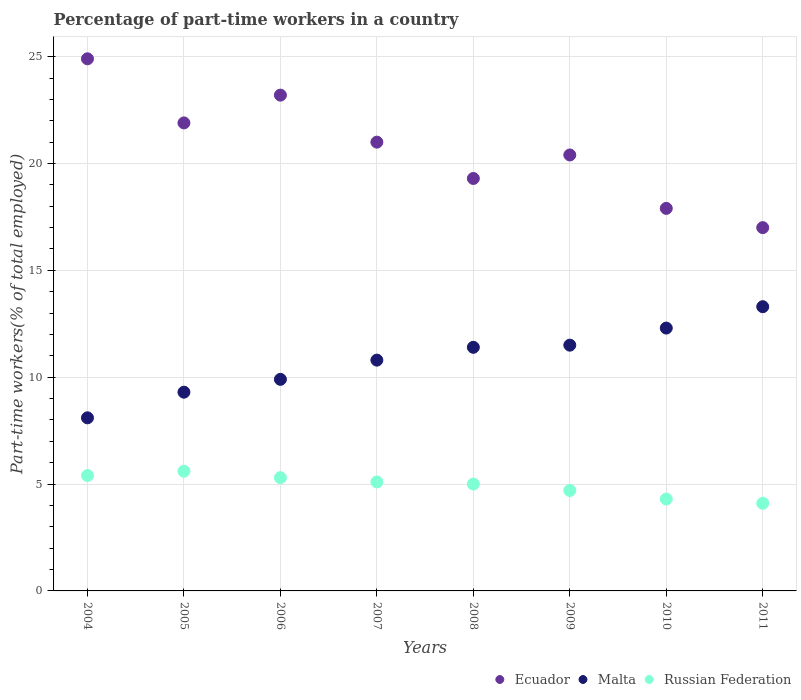Is the number of dotlines equal to the number of legend labels?
Give a very brief answer. Yes. What is the percentage of part-time workers in Malta in 2006?
Your response must be concise. 9.9. Across all years, what is the maximum percentage of part-time workers in Malta?
Ensure brevity in your answer.  13.3. Across all years, what is the minimum percentage of part-time workers in Russian Federation?
Give a very brief answer. 4.1. What is the total percentage of part-time workers in Russian Federation in the graph?
Keep it short and to the point. 39.5. What is the difference between the percentage of part-time workers in Malta in 2006 and that in 2009?
Your response must be concise. -1.6. What is the difference between the percentage of part-time workers in Ecuador in 2010 and the percentage of part-time workers in Malta in 2007?
Your answer should be compact. 7.1. What is the average percentage of part-time workers in Ecuador per year?
Your answer should be compact. 20.7. In the year 2008, what is the difference between the percentage of part-time workers in Malta and percentage of part-time workers in Ecuador?
Provide a short and direct response. -7.9. What is the ratio of the percentage of part-time workers in Russian Federation in 2007 to that in 2009?
Offer a terse response. 1.09. What is the difference between the highest and the second highest percentage of part-time workers in Ecuador?
Provide a short and direct response. 1.7. What is the difference between the highest and the lowest percentage of part-time workers in Russian Federation?
Keep it short and to the point. 1.5. In how many years, is the percentage of part-time workers in Ecuador greater than the average percentage of part-time workers in Ecuador taken over all years?
Provide a succinct answer. 4. Is the percentage of part-time workers in Russian Federation strictly greater than the percentage of part-time workers in Malta over the years?
Your response must be concise. No. How many years are there in the graph?
Provide a short and direct response. 8. What is the difference between two consecutive major ticks on the Y-axis?
Your answer should be very brief. 5. Are the values on the major ticks of Y-axis written in scientific E-notation?
Provide a short and direct response. No. Where does the legend appear in the graph?
Provide a short and direct response. Bottom right. What is the title of the graph?
Offer a very short reply. Percentage of part-time workers in a country. What is the label or title of the Y-axis?
Make the answer very short. Part-time workers(% of total employed). What is the Part-time workers(% of total employed) of Ecuador in 2004?
Your response must be concise. 24.9. What is the Part-time workers(% of total employed) in Malta in 2004?
Provide a succinct answer. 8.1. What is the Part-time workers(% of total employed) in Russian Federation in 2004?
Keep it short and to the point. 5.4. What is the Part-time workers(% of total employed) of Ecuador in 2005?
Offer a terse response. 21.9. What is the Part-time workers(% of total employed) of Malta in 2005?
Make the answer very short. 9.3. What is the Part-time workers(% of total employed) in Russian Federation in 2005?
Ensure brevity in your answer.  5.6. What is the Part-time workers(% of total employed) in Ecuador in 2006?
Offer a very short reply. 23.2. What is the Part-time workers(% of total employed) in Malta in 2006?
Your response must be concise. 9.9. What is the Part-time workers(% of total employed) in Russian Federation in 2006?
Keep it short and to the point. 5.3. What is the Part-time workers(% of total employed) in Malta in 2007?
Your response must be concise. 10.8. What is the Part-time workers(% of total employed) of Russian Federation in 2007?
Make the answer very short. 5.1. What is the Part-time workers(% of total employed) of Ecuador in 2008?
Give a very brief answer. 19.3. What is the Part-time workers(% of total employed) of Malta in 2008?
Your response must be concise. 11.4. What is the Part-time workers(% of total employed) in Ecuador in 2009?
Your answer should be very brief. 20.4. What is the Part-time workers(% of total employed) in Malta in 2009?
Make the answer very short. 11.5. What is the Part-time workers(% of total employed) of Russian Federation in 2009?
Your answer should be compact. 4.7. What is the Part-time workers(% of total employed) in Ecuador in 2010?
Keep it short and to the point. 17.9. What is the Part-time workers(% of total employed) in Malta in 2010?
Ensure brevity in your answer.  12.3. What is the Part-time workers(% of total employed) in Russian Federation in 2010?
Offer a terse response. 4.3. What is the Part-time workers(% of total employed) of Malta in 2011?
Provide a succinct answer. 13.3. What is the Part-time workers(% of total employed) in Russian Federation in 2011?
Ensure brevity in your answer.  4.1. Across all years, what is the maximum Part-time workers(% of total employed) in Ecuador?
Offer a terse response. 24.9. Across all years, what is the maximum Part-time workers(% of total employed) in Malta?
Your answer should be very brief. 13.3. Across all years, what is the maximum Part-time workers(% of total employed) in Russian Federation?
Offer a very short reply. 5.6. Across all years, what is the minimum Part-time workers(% of total employed) of Ecuador?
Make the answer very short. 17. Across all years, what is the minimum Part-time workers(% of total employed) of Malta?
Your answer should be compact. 8.1. Across all years, what is the minimum Part-time workers(% of total employed) in Russian Federation?
Ensure brevity in your answer.  4.1. What is the total Part-time workers(% of total employed) in Ecuador in the graph?
Your answer should be compact. 165.6. What is the total Part-time workers(% of total employed) in Malta in the graph?
Keep it short and to the point. 86.6. What is the total Part-time workers(% of total employed) of Russian Federation in the graph?
Make the answer very short. 39.5. What is the difference between the Part-time workers(% of total employed) in Ecuador in 2004 and that in 2005?
Your response must be concise. 3. What is the difference between the Part-time workers(% of total employed) in Russian Federation in 2004 and that in 2005?
Make the answer very short. -0.2. What is the difference between the Part-time workers(% of total employed) in Ecuador in 2004 and that in 2006?
Provide a short and direct response. 1.7. What is the difference between the Part-time workers(% of total employed) in Russian Federation in 2004 and that in 2006?
Offer a terse response. 0.1. What is the difference between the Part-time workers(% of total employed) in Ecuador in 2004 and that in 2007?
Your answer should be compact. 3.9. What is the difference between the Part-time workers(% of total employed) in Malta in 2004 and that in 2008?
Make the answer very short. -3.3. What is the difference between the Part-time workers(% of total employed) of Russian Federation in 2004 and that in 2008?
Keep it short and to the point. 0.4. What is the difference between the Part-time workers(% of total employed) in Malta in 2004 and that in 2009?
Your answer should be compact. -3.4. What is the difference between the Part-time workers(% of total employed) of Russian Federation in 2004 and that in 2009?
Offer a terse response. 0.7. What is the difference between the Part-time workers(% of total employed) in Malta in 2004 and that in 2011?
Provide a short and direct response. -5.2. What is the difference between the Part-time workers(% of total employed) in Ecuador in 2005 and that in 2006?
Your response must be concise. -1.3. What is the difference between the Part-time workers(% of total employed) in Russian Federation in 2005 and that in 2006?
Provide a succinct answer. 0.3. What is the difference between the Part-time workers(% of total employed) of Ecuador in 2005 and that in 2007?
Keep it short and to the point. 0.9. What is the difference between the Part-time workers(% of total employed) of Malta in 2005 and that in 2007?
Give a very brief answer. -1.5. What is the difference between the Part-time workers(% of total employed) in Russian Federation in 2005 and that in 2007?
Offer a very short reply. 0.5. What is the difference between the Part-time workers(% of total employed) of Russian Federation in 2005 and that in 2010?
Provide a short and direct response. 1.3. What is the difference between the Part-time workers(% of total employed) in Ecuador in 2005 and that in 2011?
Your response must be concise. 4.9. What is the difference between the Part-time workers(% of total employed) of Malta in 2006 and that in 2007?
Ensure brevity in your answer.  -0.9. What is the difference between the Part-time workers(% of total employed) in Malta in 2006 and that in 2008?
Keep it short and to the point. -1.5. What is the difference between the Part-time workers(% of total employed) in Ecuador in 2006 and that in 2009?
Offer a terse response. 2.8. What is the difference between the Part-time workers(% of total employed) in Ecuador in 2006 and that in 2010?
Offer a terse response. 5.3. What is the difference between the Part-time workers(% of total employed) in Malta in 2006 and that in 2010?
Offer a terse response. -2.4. What is the difference between the Part-time workers(% of total employed) of Ecuador in 2006 and that in 2011?
Your answer should be very brief. 6.2. What is the difference between the Part-time workers(% of total employed) in Malta in 2006 and that in 2011?
Offer a terse response. -3.4. What is the difference between the Part-time workers(% of total employed) in Ecuador in 2007 and that in 2008?
Offer a terse response. 1.7. What is the difference between the Part-time workers(% of total employed) in Malta in 2007 and that in 2008?
Give a very brief answer. -0.6. What is the difference between the Part-time workers(% of total employed) in Russian Federation in 2007 and that in 2008?
Keep it short and to the point. 0.1. What is the difference between the Part-time workers(% of total employed) in Ecuador in 2007 and that in 2009?
Offer a very short reply. 0.6. What is the difference between the Part-time workers(% of total employed) of Malta in 2007 and that in 2010?
Your answer should be very brief. -1.5. What is the difference between the Part-time workers(% of total employed) of Russian Federation in 2007 and that in 2010?
Keep it short and to the point. 0.8. What is the difference between the Part-time workers(% of total employed) in Ecuador in 2007 and that in 2011?
Provide a succinct answer. 4. What is the difference between the Part-time workers(% of total employed) of Malta in 2008 and that in 2009?
Provide a succinct answer. -0.1. What is the difference between the Part-time workers(% of total employed) in Malta in 2008 and that in 2010?
Make the answer very short. -0.9. What is the difference between the Part-time workers(% of total employed) in Ecuador in 2008 and that in 2011?
Your answer should be very brief. 2.3. What is the difference between the Part-time workers(% of total employed) of Malta in 2008 and that in 2011?
Offer a very short reply. -1.9. What is the difference between the Part-time workers(% of total employed) of Russian Federation in 2008 and that in 2011?
Provide a short and direct response. 0.9. What is the difference between the Part-time workers(% of total employed) in Ecuador in 2009 and that in 2010?
Offer a terse response. 2.5. What is the difference between the Part-time workers(% of total employed) in Malta in 2009 and that in 2010?
Ensure brevity in your answer.  -0.8. What is the difference between the Part-time workers(% of total employed) in Ecuador in 2009 and that in 2011?
Your answer should be compact. 3.4. What is the difference between the Part-time workers(% of total employed) in Malta in 2009 and that in 2011?
Give a very brief answer. -1.8. What is the difference between the Part-time workers(% of total employed) in Russian Federation in 2009 and that in 2011?
Provide a succinct answer. 0.6. What is the difference between the Part-time workers(% of total employed) in Ecuador in 2010 and that in 2011?
Offer a very short reply. 0.9. What is the difference between the Part-time workers(% of total employed) in Malta in 2010 and that in 2011?
Your answer should be very brief. -1. What is the difference between the Part-time workers(% of total employed) in Ecuador in 2004 and the Part-time workers(% of total employed) in Russian Federation in 2005?
Your answer should be very brief. 19.3. What is the difference between the Part-time workers(% of total employed) of Malta in 2004 and the Part-time workers(% of total employed) of Russian Federation in 2005?
Keep it short and to the point. 2.5. What is the difference between the Part-time workers(% of total employed) of Ecuador in 2004 and the Part-time workers(% of total employed) of Russian Federation in 2006?
Offer a very short reply. 19.6. What is the difference between the Part-time workers(% of total employed) in Malta in 2004 and the Part-time workers(% of total employed) in Russian Federation in 2006?
Ensure brevity in your answer.  2.8. What is the difference between the Part-time workers(% of total employed) in Ecuador in 2004 and the Part-time workers(% of total employed) in Malta in 2007?
Offer a very short reply. 14.1. What is the difference between the Part-time workers(% of total employed) of Ecuador in 2004 and the Part-time workers(% of total employed) of Russian Federation in 2007?
Offer a very short reply. 19.8. What is the difference between the Part-time workers(% of total employed) of Malta in 2004 and the Part-time workers(% of total employed) of Russian Federation in 2008?
Provide a short and direct response. 3.1. What is the difference between the Part-time workers(% of total employed) of Ecuador in 2004 and the Part-time workers(% of total employed) of Russian Federation in 2009?
Ensure brevity in your answer.  20.2. What is the difference between the Part-time workers(% of total employed) in Ecuador in 2004 and the Part-time workers(% of total employed) in Malta in 2010?
Provide a succinct answer. 12.6. What is the difference between the Part-time workers(% of total employed) in Ecuador in 2004 and the Part-time workers(% of total employed) in Russian Federation in 2010?
Provide a short and direct response. 20.6. What is the difference between the Part-time workers(% of total employed) in Malta in 2004 and the Part-time workers(% of total employed) in Russian Federation in 2010?
Offer a terse response. 3.8. What is the difference between the Part-time workers(% of total employed) in Ecuador in 2004 and the Part-time workers(% of total employed) in Malta in 2011?
Ensure brevity in your answer.  11.6. What is the difference between the Part-time workers(% of total employed) in Ecuador in 2004 and the Part-time workers(% of total employed) in Russian Federation in 2011?
Keep it short and to the point. 20.8. What is the difference between the Part-time workers(% of total employed) of Malta in 2004 and the Part-time workers(% of total employed) of Russian Federation in 2011?
Keep it short and to the point. 4. What is the difference between the Part-time workers(% of total employed) of Malta in 2005 and the Part-time workers(% of total employed) of Russian Federation in 2006?
Offer a very short reply. 4. What is the difference between the Part-time workers(% of total employed) in Malta in 2005 and the Part-time workers(% of total employed) in Russian Federation in 2008?
Provide a succinct answer. 4.3. What is the difference between the Part-time workers(% of total employed) in Ecuador in 2005 and the Part-time workers(% of total employed) in Malta in 2009?
Your answer should be compact. 10.4. What is the difference between the Part-time workers(% of total employed) in Ecuador in 2005 and the Part-time workers(% of total employed) in Russian Federation in 2009?
Provide a succinct answer. 17.2. What is the difference between the Part-time workers(% of total employed) in Ecuador in 2005 and the Part-time workers(% of total employed) in Russian Federation in 2010?
Give a very brief answer. 17.6. What is the difference between the Part-time workers(% of total employed) of Malta in 2005 and the Part-time workers(% of total employed) of Russian Federation in 2010?
Your answer should be very brief. 5. What is the difference between the Part-time workers(% of total employed) of Ecuador in 2005 and the Part-time workers(% of total employed) of Russian Federation in 2011?
Your answer should be compact. 17.8. What is the difference between the Part-time workers(% of total employed) of Ecuador in 2006 and the Part-time workers(% of total employed) of Malta in 2007?
Provide a short and direct response. 12.4. What is the difference between the Part-time workers(% of total employed) of Ecuador in 2006 and the Part-time workers(% of total employed) of Russian Federation in 2008?
Your response must be concise. 18.2. What is the difference between the Part-time workers(% of total employed) in Ecuador in 2006 and the Part-time workers(% of total employed) in Malta in 2009?
Offer a very short reply. 11.7. What is the difference between the Part-time workers(% of total employed) of Malta in 2006 and the Part-time workers(% of total employed) of Russian Federation in 2009?
Provide a short and direct response. 5.2. What is the difference between the Part-time workers(% of total employed) of Ecuador in 2007 and the Part-time workers(% of total employed) of Russian Federation in 2008?
Ensure brevity in your answer.  16. What is the difference between the Part-time workers(% of total employed) of Ecuador in 2007 and the Part-time workers(% of total employed) of Malta in 2009?
Ensure brevity in your answer.  9.5. What is the difference between the Part-time workers(% of total employed) in Malta in 2007 and the Part-time workers(% of total employed) in Russian Federation in 2009?
Your response must be concise. 6.1. What is the difference between the Part-time workers(% of total employed) of Ecuador in 2007 and the Part-time workers(% of total employed) of Russian Federation in 2010?
Your answer should be compact. 16.7. What is the difference between the Part-time workers(% of total employed) in Ecuador in 2007 and the Part-time workers(% of total employed) in Russian Federation in 2011?
Provide a short and direct response. 16.9. What is the difference between the Part-time workers(% of total employed) of Ecuador in 2008 and the Part-time workers(% of total employed) of Malta in 2009?
Provide a short and direct response. 7.8. What is the difference between the Part-time workers(% of total employed) in Malta in 2008 and the Part-time workers(% of total employed) in Russian Federation in 2009?
Offer a very short reply. 6.7. What is the difference between the Part-time workers(% of total employed) of Malta in 2008 and the Part-time workers(% of total employed) of Russian Federation in 2010?
Provide a succinct answer. 7.1. What is the difference between the Part-time workers(% of total employed) in Ecuador in 2008 and the Part-time workers(% of total employed) in Russian Federation in 2011?
Your answer should be very brief. 15.2. What is the difference between the Part-time workers(% of total employed) in Ecuador in 2009 and the Part-time workers(% of total employed) in Malta in 2011?
Provide a succinct answer. 7.1. What is the difference between the Part-time workers(% of total employed) of Ecuador in 2009 and the Part-time workers(% of total employed) of Russian Federation in 2011?
Your response must be concise. 16.3. What is the difference between the Part-time workers(% of total employed) of Ecuador in 2010 and the Part-time workers(% of total employed) of Russian Federation in 2011?
Provide a succinct answer. 13.8. What is the difference between the Part-time workers(% of total employed) in Malta in 2010 and the Part-time workers(% of total employed) in Russian Federation in 2011?
Ensure brevity in your answer.  8.2. What is the average Part-time workers(% of total employed) in Ecuador per year?
Keep it short and to the point. 20.7. What is the average Part-time workers(% of total employed) in Malta per year?
Provide a succinct answer. 10.82. What is the average Part-time workers(% of total employed) in Russian Federation per year?
Provide a succinct answer. 4.94. In the year 2004, what is the difference between the Part-time workers(% of total employed) of Malta and Part-time workers(% of total employed) of Russian Federation?
Your answer should be very brief. 2.7. In the year 2005, what is the difference between the Part-time workers(% of total employed) of Ecuador and Part-time workers(% of total employed) of Russian Federation?
Make the answer very short. 16.3. In the year 2006, what is the difference between the Part-time workers(% of total employed) of Ecuador and Part-time workers(% of total employed) of Malta?
Make the answer very short. 13.3. In the year 2007, what is the difference between the Part-time workers(% of total employed) of Ecuador and Part-time workers(% of total employed) of Russian Federation?
Offer a very short reply. 15.9. In the year 2007, what is the difference between the Part-time workers(% of total employed) in Malta and Part-time workers(% of total employed) in Russian Federation?
Offer a terse response. 5.7. In the year 2008, what is the difference between the Part-time workers(% of total employed) of Ecuador and Part-time workers(% of total employed) of Malta?
Provide a short and direct response. 7.9. In the year 2008, what is the difference between the Part-time workers(% of total employed) in Ecuador and Part-time workers(% of total employed) in Russian Federation?
Ensure brevity in your answer.  14.3. In the year 2009, what is the difference between the Part-time workers(% of total employed) of Ecuador and Part-time workers(% of total employed) of Malta?
Offer a terse response. 8.9. In the year 2009, what is the difference between the Part-time workers(% of total employed) of Ecuador and Part-time workers(% of total employed) of Russian Federation?
Provide a succinct answer. 15.7. In the year 2010, what is the difference between the Part-time workers(% of total employed) in Malta and Part-time workers(% of total employed) in Russian Federation?
Provide a short and direct response. 8. What is the ratio of the Part-time workers(% of total employed) in Ecuador in 2004 to that in 2005?
Make the answer very short. 1.14. What is the ratio of the Part-time workers(% of total employed) in Malta in 2004 to that in 2005?
Make the answer very short. 0.87. What is the ratio of the Part-time workers(% of total employed) in Ecuador in 2004 to that in 2006?
Your response must be concise. 1.07. What is the ratio of the Part-time workers(% of total employed) of Malta in 2004 to that in 2006?
Give a very brief answer. 0.82. What is the ratio of the Part-time workers(% of total employed) in Russian Federation in 2004 to that in 2006?
Keep it short and to the point. 1.02. What is the ratio of the Part-time workers(% of total employed) in Ecuador in 2004 to that in 2007?
Make the answer very short. 1.19. What is the ratio of the Part-time workers(% of total employed) in Malta in 2004 to that in 2007?
Your response must be concise. 0.75. What is the ratio of the Part-time workers(% of total employed) in Russian Federation in 2004 to that in 2007?
Provide a succinct answer. 1.06. What is the ratio of the Part-time workers(% of total employed) of Ecuador in 2004 to that in 2008?
Offer a very short reply. 1.29. What is the ratio of the Part-time workers(% of total employed) of Malta in 2004 to that in 2008?
Offer a terse response. 0.71. What is the ratio of the Part-time workers(% of total employed) of Russian Federation in 2004 to that in 2008?
Provide a succinct answer. 1.08. What is the ratio of the Part-time workers(% of total employed) of Ecuador in 2004 to that in 2009?
Provide a succinct answer. 1.22. What is the ratio of the Part-time workers(% of total employed) of Malta in 2004 to that in 2009?
Ensure brevity in your answer.  0.7. What is the ratio of the Part-time workers(% of total employed) in Russian Federation in 2004 to that in 2009?
Offer a very short reply. 1.15. What is the ratio of the Part-time workers(% of total employed) of Ecuador in 2004 to that in 2010?
Offer a very short reply. 1.39. What is the ratio of the Part-time workers(% of total employed) in Malta in 2004 to that in 2010?
Your response must be concise. 0.66. What is the ratio of the Part-time workers(% of total employed) of Russian Federation in 2004 to that in 2010?
Provide a succinct answer. 1.26. What is the ratio of the Part-time workers(% of total employed) of Ecuador in 2004 to that in 2011?
Your answer should be very brief. 1.46. What is the ratio of the Part-time workers(% of total employed) in Malta in 2004 to that in 2011?
Offer a very short reply. 0.61. What is the ratio of the Part-time workers(% of total employed) in Russian Federation in 2004 to that in 2011?
Ensure brevity in your answer.  1.32. What is the ratio of the Part-time workers(% of total employed) in Ecuador in 2005 to that in 2006?
Ensure brevity in your answer.  0.94. What is the ratio of the Part-time workers(% of total employed) of Malta in 2005 to that in 2006?
Your answer should be compact. 0.94. What is the ratio of the Part-time workers(% of total employed) of Russian Federation in 2005 to that in 2006?
Keep it short and to the point. 1.06. What is the ratio of the Part-time workers(% of total employed) of Ecuador in 2005 to that in 2007?
Provide a short and direct response. 1.04. What is the ratio of the Part-time workers(% of total employed) in Malta in 2005 to that in 2007?
Provide a succinct answer. 0.86. What is the ratio of the Part-time workers(% of total employed) in Russian Federation in 2005 to that in 2007?
Offer a very short reply. 1.1. What is the ratio of the Part-time workers(% of total employed) of Ecuador in 2005 to that in 2008?
Ensure brevity in your answer.  1.13. What is the ratio of the Part-time workers(% of total employed) of Malta in 2005 to that in 2008?
Provide a short and direct response. 0.82. What is the ratio of the Part-time workers(% of total employed) of Russian Federation in 2005 to that in 2008?
Your response must be concise. 1.12. What is the ratio of the Part-time workers(% of total employed) of Ecuador in 2005 to that in 2009?
Provide a short and direct response. 1.07. What is the ratio of the Part-time workers(% of total employed) in Malta in 2005 to that in 2009?
Make the answer very short. 0.81. What is the ratio of the Part-time workers(% of total employed) of Russian Federation in 2005 to that in 2009?
Ensure brevity in your answer.  1.19. What is the ratio of the Part-time workers(% of total employed) of Ecuador in 2005 to that in 2010?
Offer a very short reply. 1.22. What is the ratio of the Part-time workers(% of total employed) of Malta in 2005 to that in 2010?
Make the answer very short. 0.76. What is the ratio of the Part-time workers(% of total employed) in Russian Federation in 2005 to that in 2010?
Make the answer very short. 1.3. What is the ratio of the Part-time workers(% of total employed) of Ecuador in 2005 to that in 2011?
Give a very brief answer. 1.29. What is the ratio of the Part-time workers(% of total employed) in Malta in 2005 to that in 2011?
Offer a very short reply. 0.7. What is the ratio of the Part-time workers(% of total employed) of Russian Federation in 2005 to that in 2011?
Keep it short and to the point. 1.37. What is the ratio of the Part-time workers(% of total employed) of Ecuador in 2006 to that in 2007?
Offer a terse response. 1.1. What is the ratio of the Part-time workers(% of total employed) of Malta in 2006 to that in 2007?
Give a very brief answer. 0.92. What is the ratio of the Part-time workers(% of total employed) of Russian Federation in 2006 to that in 2007?
Provide a short and direct response. 1.04. What is the ratio of the Part-time workers(% of total employed) of Ecuador in 2006 to that in 2008?
Make the answer very short. 1.2. What is the ratio of the Part-time workers(% of total employed) in Malta in 2006 to that in 2008?
Give a very brief answer. 0.87. What is the ratio of the Part-time workers(% of total employed) of Russian Federation in 2006 to that in 2008?
Your answer should be compact. 1.06. What is the ratio of the Part-time workers(% of total employed) in Ecuador in 2006 to that in 2009?
Your answer should be compact. 1.14. What is the ratio of the Part-time workers(% of total employed) of Malta in 2006 to that in 2009?
Make the answer very short. 0.86. What is the ratio of the Part-time workers(% of total employed) in Russian Federation in 2006 to that in 2009?
Keep it short and to the point. 1.13. What is the ratio of the Part-time workers(% of total employed) of Ecuador in 2006 to that in 2010?
Offer a very short reply. 1.3. What is the ratio of the Part-time workers(% of total employed) of Malta in 2006 to that in 2010?
Offer a very short reply. 0.8. What is the ratio of the Part-time workers(% of total employed) of Russian Federation in 2006 to that in 2010?
Provide a succinct answer. 1.23. What is the ratio of the Part-time workers(% of total employed) of Ecuador in 2006 to that in 2011?
Your answer should be compact. 1.36. What is the ratio of the Part-time workers(% of total employed) of Malta in 2006 to that in 2011?
Provide a short and direct response. 0.74. What is the ratio of the Part-time workers(% of total employed) of Russian Federation in 2006 to that in 2011?
Provide a succinct answer. 1.29. What is the ratio of the Part-time workers(% of total employed) in Ecuador in 2007 to that in 2008?
Your response must be concise. 1.09. What is the ratio of the Part-time workers(% of total employed) in Malta in 2007 to that in 2008?
Ensure brevity in your answer.  0.95. What is the ratio of the Part-time workers(% of total employed) of Russian Federation in 2007 to that in 2008?
Your response must be concise. 1.02. What is the ratio of the Part-time workers(% of total employed) of Ecuador in 2007 to that in 2009?
Make the answer very short. 1.03. What is the ratio of the Part-time workers(% of total employed) of Malta in 2007 to that in 2009?
Offer a very short reply. 0.94. What is the ratio of the Part-time workers(% of total employed) of Russian Federation in 2007 to that in 2009?
Provide a succinct answer. 1.09. What is the ratio of the Part-time workers(% of total employed) of Ecuador in 2007 to that in 2010?
Provide a short and direct response. 1.17. What is the ratio of the Part-time workers(% of total employed) in Malta in 2007 to that in 2010?
Give a very brief answer. 0.88. What is the ratio of the Part-time workers(% of total employed) of Russian Federation in 2007 to that in 2010?
Offer a terse response. 1.19. What is the ratio of the Part-time workers(% of total employed) in Ecuador in 2007 to that in 2011?
Your answer should be compact. 1.24. What is the ratio of the Part-time workers(% of total employed) in Malta in 2007 to that in 2011?
Your answer should be compact. 0.81. What is the ratio of the Part-time workers(% of total employed) of Russian Federation in 2007 to that in 2011?
Provide a succinct answer. 1.24. What is the ratio of the Part-time workers(% of total employed) in Ecuador in 2008 to that in 2009?
Keep it short and to the point. 0.95. What is the ratio of the Part-time workers(% of total employed) in Malta in 2008 to that in 2009?
Provide a short and direct response. 0.99. What is the ratio of the Part-time workers(% of total employed) in Russian Federation in 2008 to that in 2009?
Keep it short and to the point. 1.06. What is the ratio of the Part-time workers(% of total employed) in Ecuador in 2008 to that in 2010?
Offer a terse response. 1.08. What is the ratio of the Part-time workers(% of total employed) of Malta in 2008 to that in 2010?
Offer a very short reply. 0.93. What is the ratio of the Part-time workers(% of total employed) in Russian Federation in 2008 to that in 2010?
Keep it short and to the point. 1.16. What is the ratio of the Part-time workers(% of total employed) of Ecuador in 2008 to that in 2011?
Your answer should be compact. 1.14. What is the ratio of the Part-time workers(% of total employed) of Malta in 2008 to that in 2011?
Your answer should be compact. 0.86. What is the ratio of the Part-time workers(% of total employed) of Russian Federation in 2008 to that in 2011?
Offer a terse response. 1.22. What is the ratio of the Part-time workers(% of total employed) of Ecuador in 2009 to that in 2010?
Offer a terse response. 1.14. What is the ratio of the Part-time workers(% of total employed) in Malta in 2009 to that in 2010?
Your answer should be compact. 0.94. What is the ratio of the Part-time workers(% of total employed) of Russian Federation in 2009 to that in 2010?
Your response must be concise. 1.09. What is the ratio of the Part-time workers(% of total employed) of Malta in 2009 to that in 2011?
Keep it short and to the point. 0.86. What is the ratio of the Part-time workers(% of total employed) of Russian Federation in 2009 to that in 2011?
Your answer should be compact. 1.15. What is the ratio of the Part-time workers(% of total employed) of Ecuador in 2010 to that in 2011?
Give a very brief answer. 1.05. What is the ratio of the Part-time workers(% of total employed) of Malta in 2010 to that in 2011?
Ensure brevity in your answer.  0.92. What is the ratio of the Part-time workers(% of total employed) of Russian Federation in 2010 to that in 2011?
Your response must be concise. 1.05. What is the difference between the highest and the second highest Part-time workers(% of total employed) in Ecuador?
Keep it short and to the point. 1.7. What is the difference between the highest and the second highest Part-time workers(% of total employed) in Russian Federation?
Give a very brief answer. 0.2. 